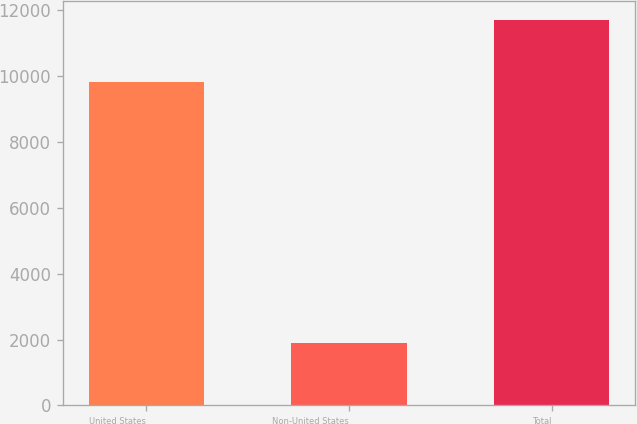<chart> <loc_0><loc_0><loc_500><loc_500><bar_chart><fcel>United States<fcel>Non-United States<fcel>Total<nl><fcel>9810.6<fcel>1900.7<fcel>11711.3<nl></chart> 